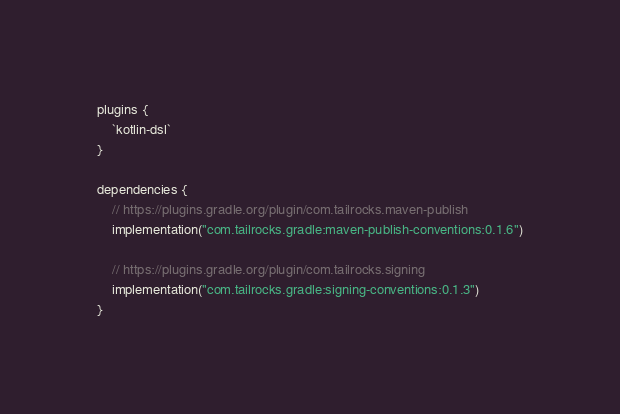Convert code to text. <code><loc_0><loc_0><loc_500><loc_500><_Kotlin_>plugins {
    `kotlin-dsl`
}

dependencies {
    // https://plugins.gradle.org/plugin/com.tailrocks.maven-publish
    implementation("com.tailrocks.gradle:maven-publish-conventions:0.1.6")

    // https://plugins.gradle.org/plugin/com.tailrocks.signing
    implementation("com.tailrocks.gradle:signing-conventions:0.1.3")
}
</code> 